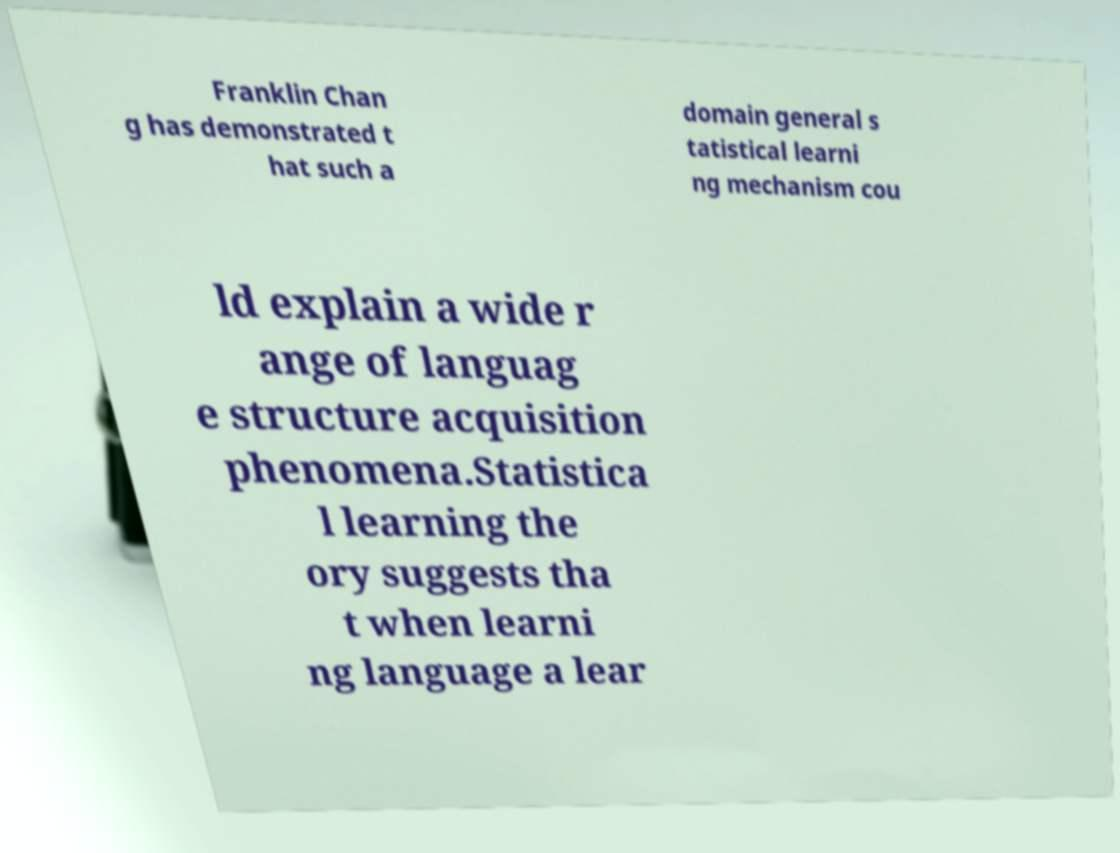For documentation purposes, I need the text within this image transcribed. Could you provide that? Franklin Chan g has demonstrated t hat such a domain general s tatistical learni ng mechanism cou ld explain a wide r ange of languag e structure acquisition phenomena.Statistica l learning the ory suggests tha t when learni ng language a lear 